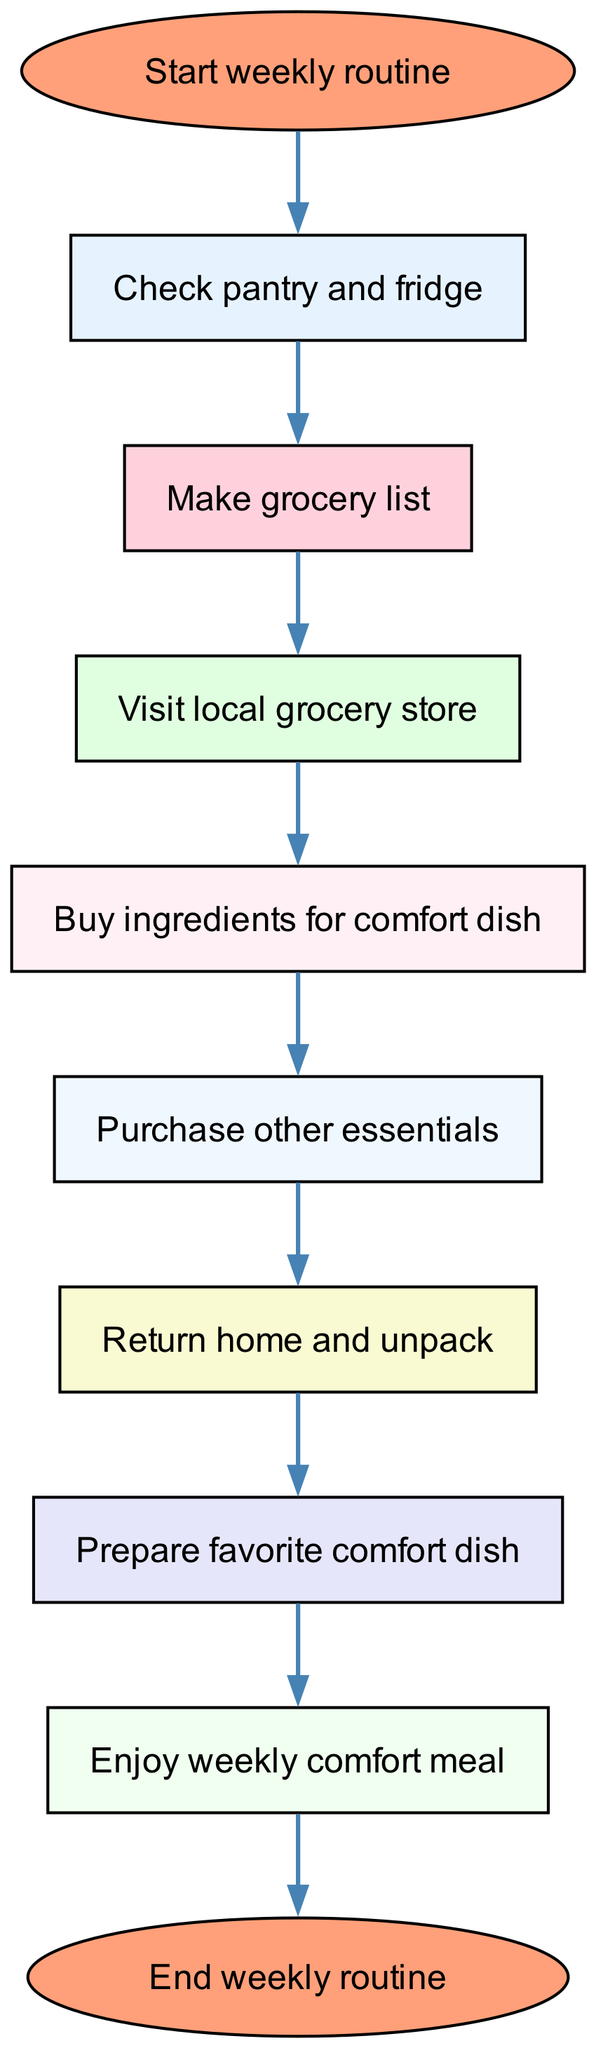What is the first step in the weekly routine? The diagram starts with the node labeled "Start weekly routine," which is the initial step before any action is taken.
Answer: Start weekly routine How many steps are there in the flow chart? By counting each node in the flow chart, we find there are ten distinct steps from start to end.
Answer: Ten What is the last action taken in this routine? Following the flow of the diagram, the last action taken before completing the routine is "Enjoy weekly comfort meal."
Answer: Enjoy weekly comfort meal Which node immediately follows "Visit local grocery store"? The connection from "Visit local grocery store" leads directly to the next step, which is "Buy ingredients for comfort dish."
Answer: Buy ingredients for comfort dish Which step comes before "Prepare favorite comfort dish"? The flow of the diagram indicates that "Return home and unpack" is the step that takes place just before preparing the comfort dish.
Answer: Return home and unpack What action is performed after checking the pantry and fridge? After the action of checking the pantry and fridge, the next task in the process is to "Make grocery list."
Answer: Make grocery list How many connections are there in the flow chart? By analyzing the connections, we can count a total of nine distinct edges that represent the flow from one step to another.
Answer: Nine What specific item is bought after gathering ingredients for the comfort dish? The diagram specifies that the subsequent action is to "Purchase other essentials" after buying the ingredients.
Answer: Purchase other essentials What type of flow is represented in this diagram? The diagram represents a directed flow where each step leads to the next in a defined and sequential manner.
Answer: Directed flow 